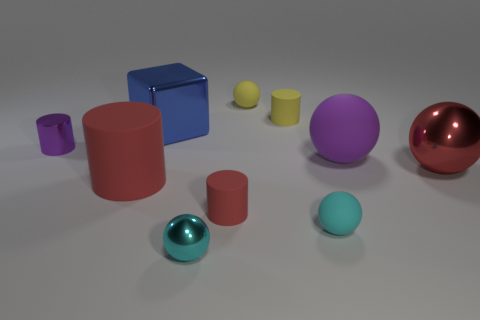Do the large rubber sphere and the metal cylinder have the same color?
Your response must be concise. Yes. There is a big red object that is to the left of the small rubber ball that is to the right of the rubber ball behind the purple ball; what is its shape?
Provide a succinct answer. Cylinder. How many objects are either large cyan metal objects or rubber objects on the right side of the big cylinder?
Make the answer very short. 5. There is a shiny sphere in front of the small cyan rubber thing; what is its size?
Provide a succinct answer. Small. There is a metal thing that is the same color as the big matte cylinder; what is its shape?
Give a very brief answer. Sphere. Does the purple cylinder have the same material as the big sphere in front of the purple rubber object?
Provide a short and direct response. Yes. There is a tiny ball that is behind the small metal thing that is behind the cyan metal object; what number of rubber spheres are on the right side of it?
Keep it short and to the point. 2. What number of red things are either tiny spheres or matte spheres?
Your answer should be compact. 0. There is a purple thing in front of the small purple shiny cylinder; what shape is it?
Provide a succinct answer. Sphere. The matte cylinder that is the same size as the red sphere is what color?
Offer a terse response. Red. 